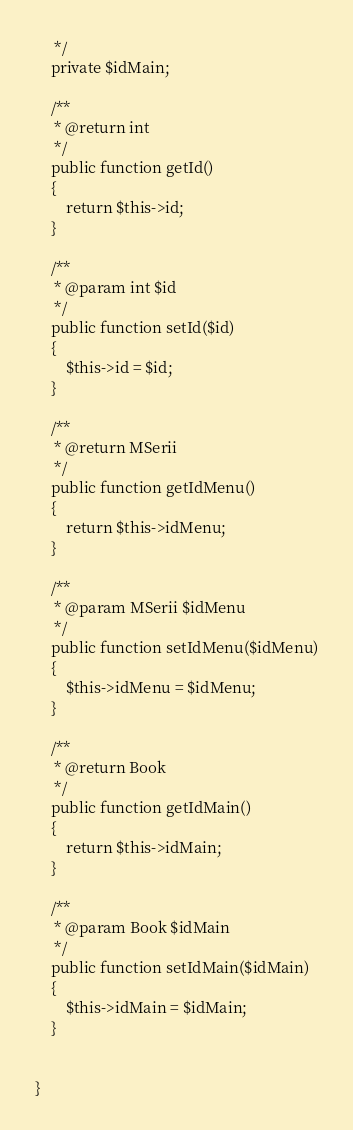Convert code to text. <code><loc_0><loc_0><loc_500><loc_500><_PHP_>     */
    private $idMain;

    /**
     * @return int
     */
    public function getId()
    {
        return $this->id;
    }

    /**
     * @param int $id
     */
    public function setId($id)
    {
        $this->id = $id;
    }

    /**
     * @return MSerii
     */
    public function getIdMenu()
    {
        return $this->idMenu;
    }

    /**
     * @param MSerii $idMenu
     */
    public function setIdMenu($idMenu)
    {
        $this->idMenu = $idMenu;
    }

    /**
     * @return Book
     */
    public function getIdMain()
    {
        return $this->idMain;
    }

    /**
     * @param Book $idMain
     */
    public function setIdMain($idMain)
    {
        $this->idMain = $idMain;
    }


}
</code> 